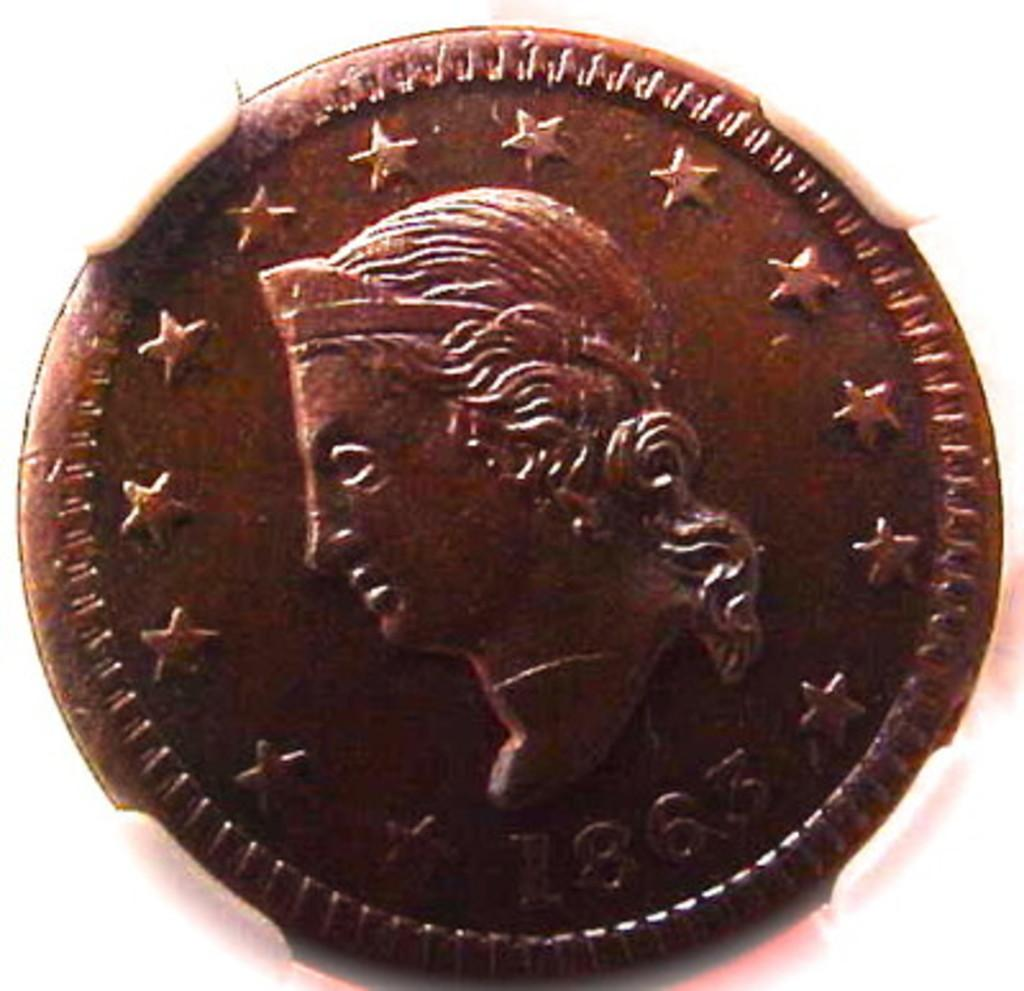<image>
Write a terse but informative summary of the picture. A blurry shot of an old coin dated from the year 1863 